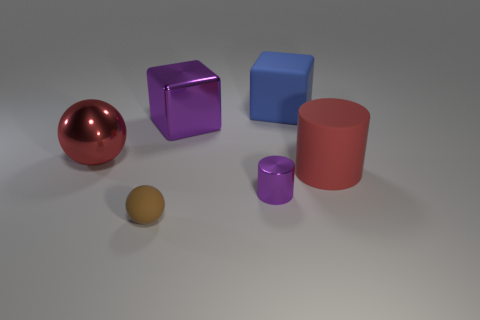How would you describe the lighting and shadow effects in the scene? The lighting in the scene is soft and diffused, casting gentle shadows that stretch away from the objects, suggesting an overhead light source that is not too harsh. The shadows help to give a sense of the shape and texture of the objects, enhancing the three-dimensional feel of the image. 